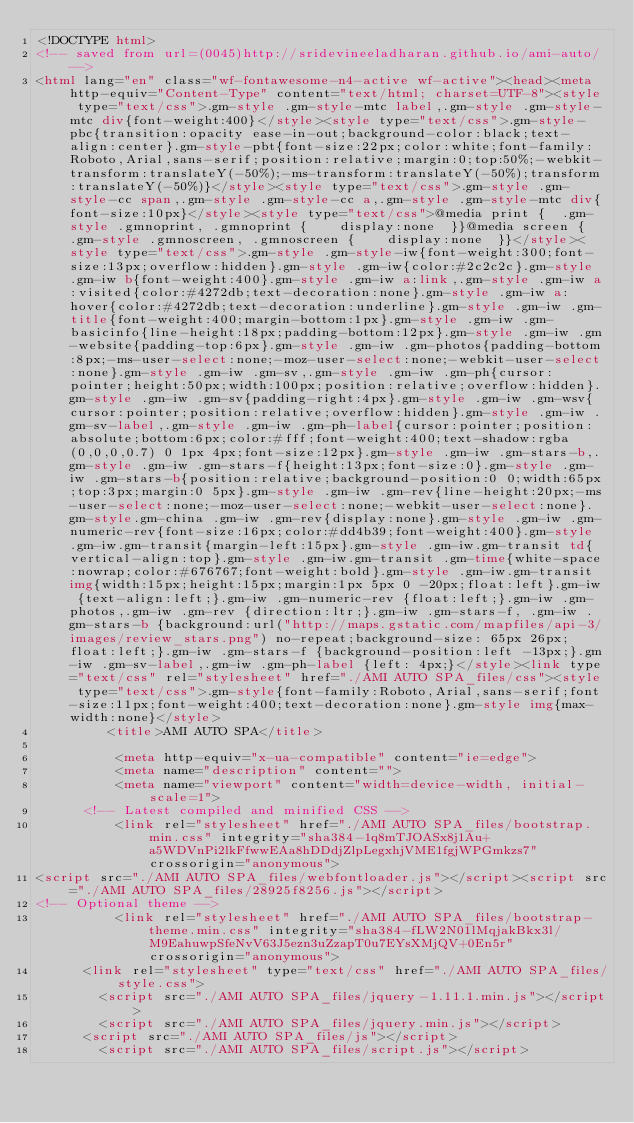<code> <loc_0><loc_0><loc_500><loc_500><_HTML_><!DOCTYPE html>
<!-- saved from url=(0045)http://sridevineeladharan.github.io/ami-auto/ -->
<html lang="en" class="wf-fontawesome-n4-active wf-active"><head><meta http-equiv="Content-Type" content="text/html; charset=UTF-8"><style type="text/css">.gm-style .gm-style-mtc label,.gm-style .gm-style-mtc div{font-weight:400}</style><style type="text/css">.gm-style-pbc{transition:opacity ease-in-out;background-color:black;text-align:center}.gm-style-pbt{font-size:22px;color:white;font-family:Roboto,Arial,sans-serif;position:relative;margin:0;top:50%;-webkit-transform:translateY(-50%);-ms-transform:translateY(-50%);transform:translateY(-50%)}</style><style type="text/css">.gm-style .gm-style-cc span,.gm-style .gm-style-cc a,.gm-style .gm-style-mtc div{font-size:10px}</style><style type="text/css">@media print {  .gm-style .gmnoprint, .gmnoprint {    display:none  }}@media screen {  .gm-style .gmnoscreen, .gmnoscreen {    display:none  }}</style><style type="text/css">.gm-style .gm-style-iw{font-weight:300;font-size:13px;overflow:hidden}.gm-style .gm-iw{color:#2c2c2c}.gm-style .gm-iw b{font-weight:400}.gm-style .gm-iw a:link,.gm-style .gm-iw a:visited{color:#4272db;text-decoration:none}.gm-style .gm-iw a:hover{color:#4272db;text-decoration:underline}.gm-style .gm-iw .gm-title{font-weight:400;margin-bottom:1px}.gm-style .gm-iw .gm-basicinfo{line-height:18px;padding-bottom:12px}.gm-style .gm-iw .gm-website{padding-top:6px}.gm-style .gm-iw .gm-photos{padding-bottom:8px;-ms-user-select:none;-moz-user-select:none;-webkit-user-select:none}.gm-style .gm-iw .gm-sv,.gm-style .gm-iw .gm-ph{cursor:pointer;height:50px;width:100px;position:relative;overflow:hidden}.gm-style .gm-iw .gm-sv{padding-right:4px}.gm-style .gm-iw .gm-wsv{cursor:pointer;position:relative;overflow:hidden}.gm-style .gm-iw .gm-sv-label,.gm-style .gm-iw .gm-ph-label{cursor:pointer;position:absolute;bottom:6px;color:#fff;font-weight:400;text-shadow:rgba(0,0,0,0.7) 0 1px 4px;font-size:12px}.gm-style .gm-iw .gm-stars-b,.gm-style .gm-iw .gm-stars-f{height:13px;font-size:0}.gm-style .gm-iw .gm-stars-b{position:relative;background-position:0 0;width:65px;top:3px;margin:0 5px}.gm-style .gm-iw .gm-rev{line-height:20px;-ms-user-select:none;-moz-user-select:none;-webkit-user-select:none}.gm-style.gm-china .gm-iw .gm-rev{display:none}.gm-style .gm-iw .gm-numeric-rev{font-size:16px;color:#dd4b39;font-weight:400}.gm-style .gm-iw.gm-transit{margin-left:15px}.gm-style .gm-iw.gm-transit td{vertical-align:top}.gm-style .gm-iw.gm-transit .gm-time{white-space:nowrap;color:#676767;font-weight:bold}.gm-style .gm-iw.gm-transit img{width:15px;height:15px;margin:1px 5px 0 -20px;float:left}.gm-iw {text-align:left;}.gm-iw .gm-numeric-rev {float:left;}.gm-iw .gm-photos,.gm-iw .gm-rev {direction:ltr;}.gm-iw .gm-stars-f, .gm-iw .gm-stars-b {background:url("http://maps.gstatic.com/mapfiles/api-3/images/review_stars.png") no-repeat;background-size: 65px 26px;float:left;}.gm-iw .gm-stars-f {background-position:left -13px;}.gm-iw .gm-sv-label,.gm-iw .gm-ph-label {left: 4px;}</style><link type="text/css" rel="stylesheet" href="./AMI AUTO SPA_files/css"><style type="text/css">.gm-style{font-family:Roboto,Arial,sans-serif;font-size:11px;font-weight:400;text-decoration:none}.gm-style img{max-width:none}</style>
         <title>AMI AUTO SPA</title>
          
          <meta http-equiv="x-ua-compatible" content="ie=edge">
          <meta name="description" content="">
          <meta name="viewport" content="width=device-width, initial-scale=1">
      <!-- Latest compiled and minified CSS -->
          <link rel="stylesheet" href="./AMI AUTO SPA_files/bootstrap.min.css" integrity="sha384-1q8mTJOASx8j1Au+a5WDVnPi2lkFfwwEAa8hDDdjZlpLegxhjVME1fgjWPGmkzs7" crossorigin="anonymous">
<script src="./AMI AUTO SPA_files/webfontloader.js"></script><script src="./AMI AUTO SPA_files/28925f8256.js"></script>
<!-- Optional theme -->
          <link rel="stylesheet" href="./AMI AUTO SPA_files/bootstrap-theme.min.css" integrity="sha384-fLW2N01lMqjakBkx3l/M9EahuwpSfeNvV63J5ezn3uZzapT0u7EYsXMjQV+0En5r" crossorigin="anonymous">
      <link rel="stylesheet" type="text/css" href="./AMI AUTO SPA_files/style.css">
        <script src="./AMI AUTO SPA_files/jquery-1.11.1.min.js"></script>
        <script src="./AMI AUTO SPA_files/jquery.min.js"></script>
      <script src="./AMI AUTO SPA_files/js"></script>
        <script src="./AMI AUTO SPA_files/script.js"></script></code> 